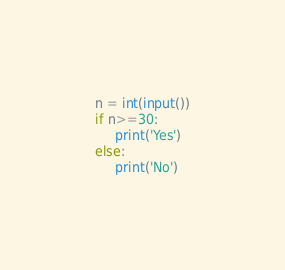Convert code to text. <code><loc_0><loc_0><loc_500><loc_500><_Python_>
n = int(input())
if n>=30:
     print('Yes')
else:
     print('No')</code> 